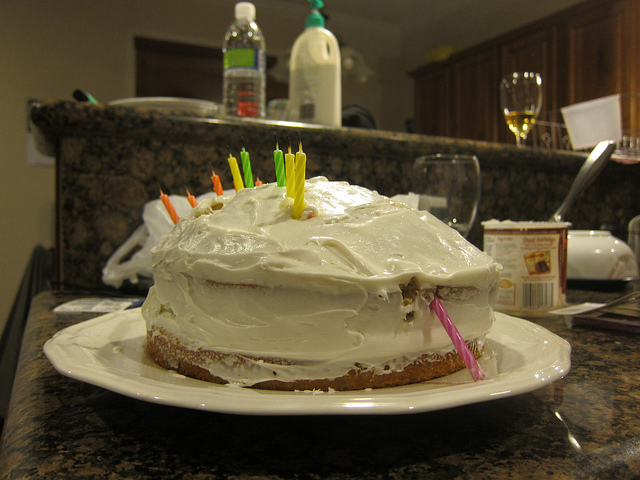How many cakes are there? 1 